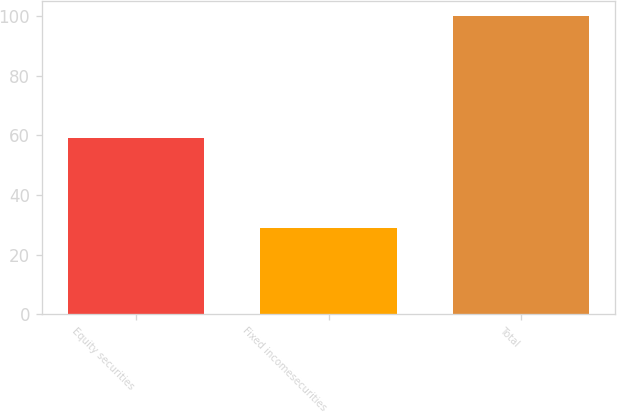<chart> <loc_0><loc_0><loc_500><loc_500><bar_chart><fcel>Equity securities<fcel>Fixed incomesecurities<fcel>Total<nl><fcel>59<fcel>29<fcel>100<nl></chart> 